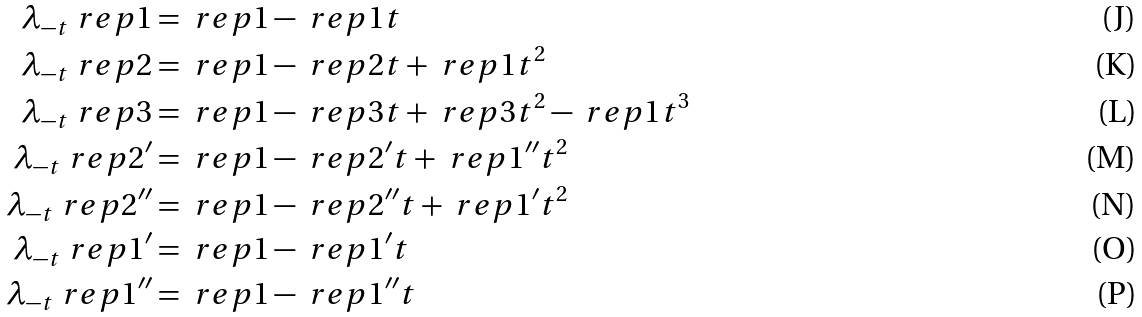Convert formula to latex. <formula><loc_0><loc_0><loc_500><loc_500>\lambda _ { - t } \ r e p { 1 } & = \ r e p { 1 } - \ r e p { 1 } t \\ \lambda _ { - t } \ r e p { 2 } & = \ r e p { 1 } - \ r e p { 2 } t + \ r e p { 1 } t ^ { 2 } \\ \lambda _ { - t } \ r e p { 3 } & = \ r e p { 1 } - \ r e p { 3 } t + \ r e p { 3 } t ^ { 2 } - \ r e p { 1 } t ^ { 3 } \\ \lambda _ { - t } \ r e p { 2 ^ { \prime } } & = \ r e p { 1 } - \ r e p { 2 ^ { \prime } } t + \ r e p { 1 ^ { \prime \prime } } t ^ { 2 } \\ \lambda _ { - t } \ r e p { 2 ^ { \prime \prime } } & = \ r e p { 1 } - \ r e p { 2 ^ { \prime \prime } } t + \ r e p { 1 ^ { \prime } } t ^ { 2 } \\ \lambda _ { - t } \ r e p { 1 ^ { \prime } } & = \ r e p { 1 } - \ r e p { 1 ^ { \prime } } t \\ \lambda _ { - t } \ r e p { 1 ^ { \prime \prime } } & = \ r e p { 1 } - \ r e p { 1 ^ { \prime \prime } } t</formula> 